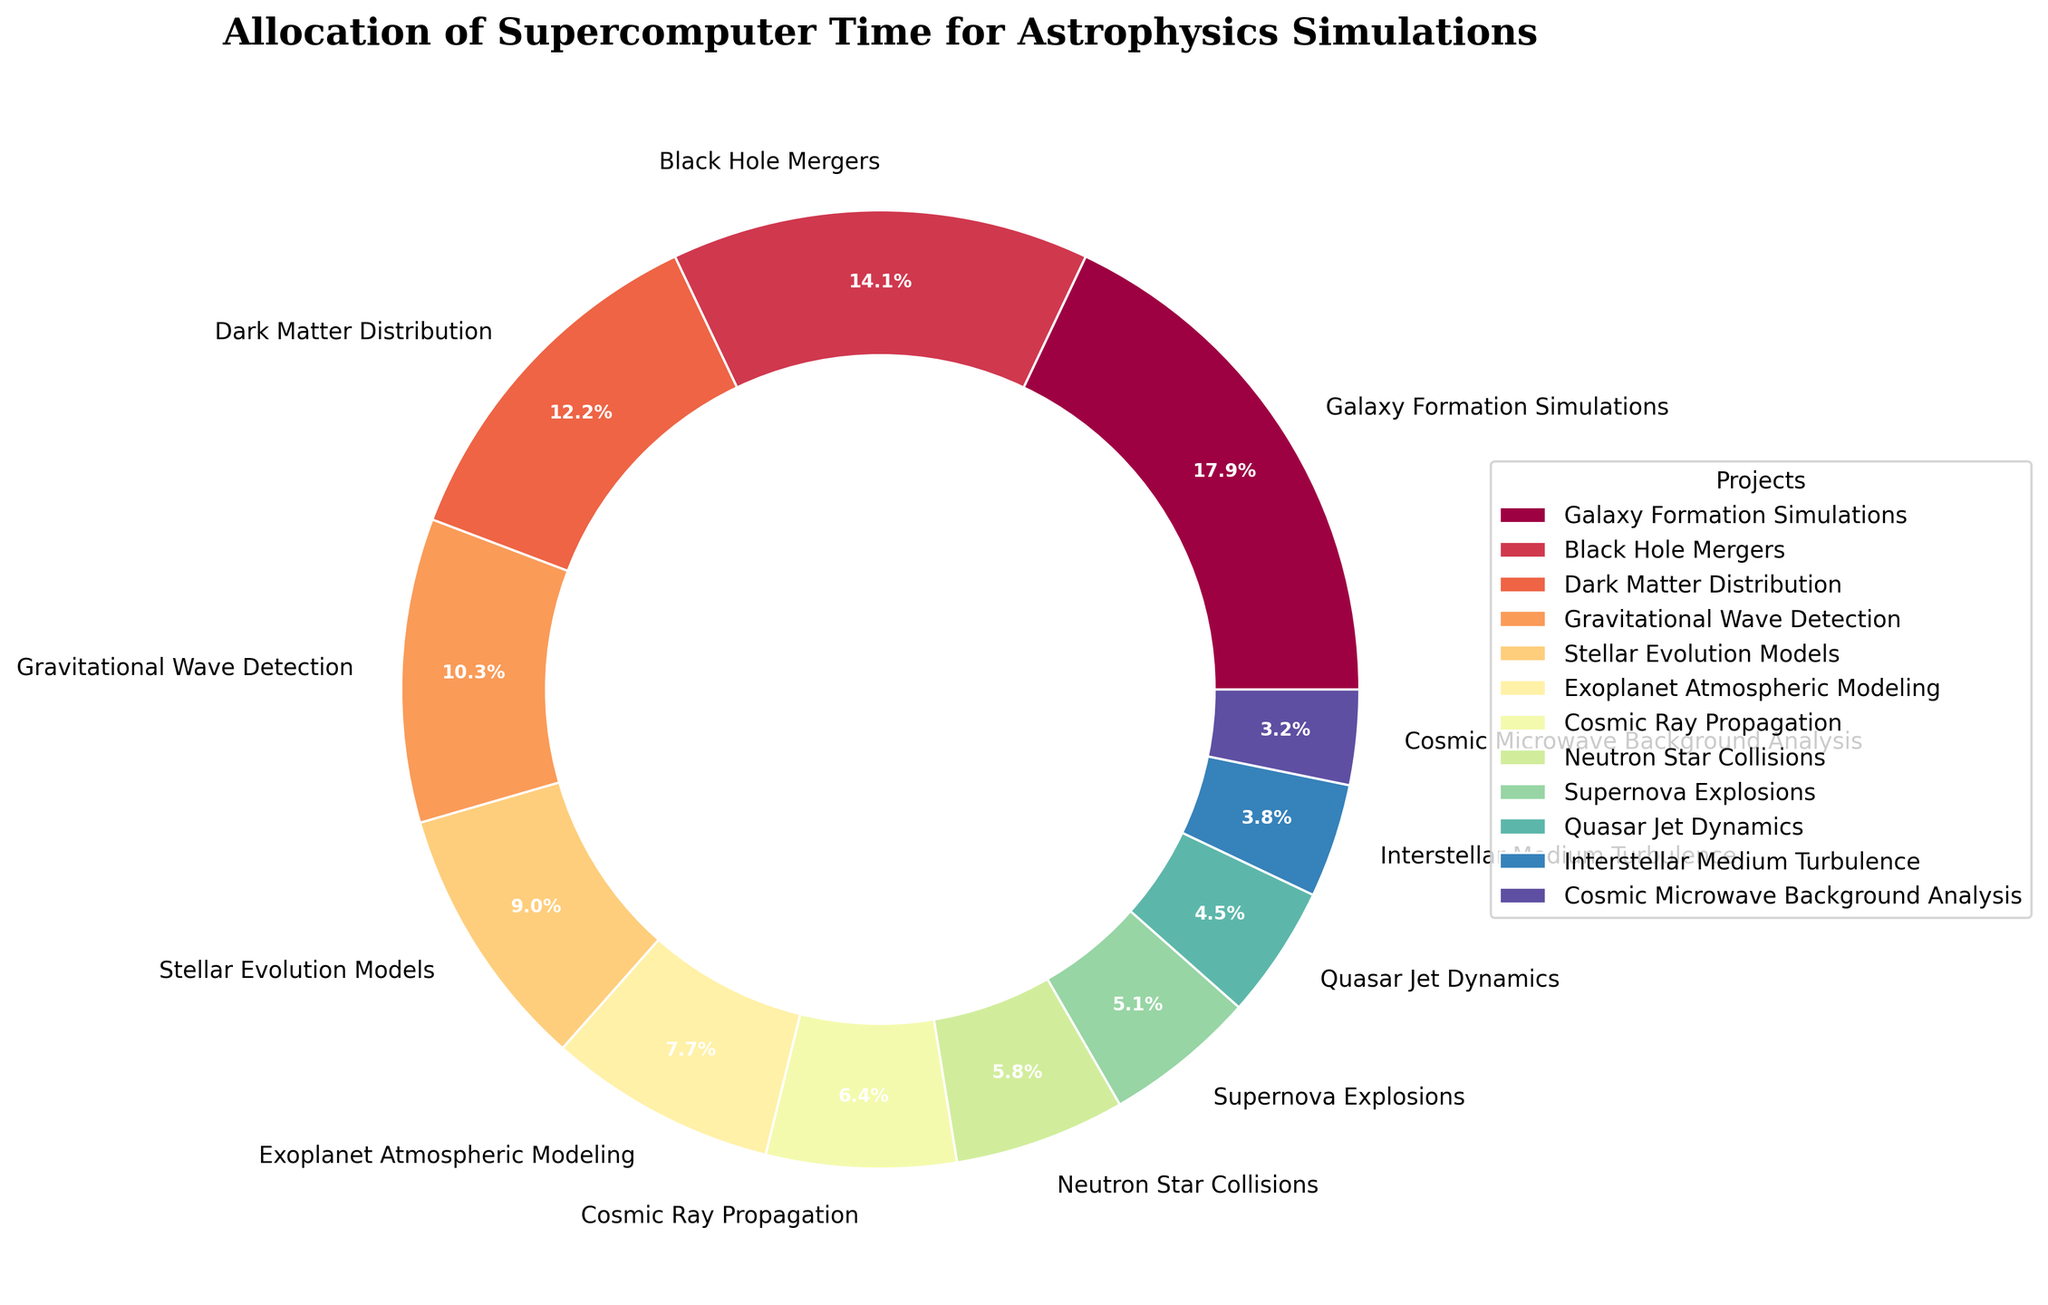what percentage of the total supercomputer time is allocated to Galaxy Formation Simulations? Look at the pie chart and find the segment labeled "Galaxy Formation Simulations." The percentage value displayed on or near this segment is the answer.
Answer: 23.1% Which project has the smallest allocation of supercomputer time? Identify the segment on the pie chart with the smallest size, which represents the smallest percentage. The label near this segment reveals the project with the smallest allocation.
Answer: Cosmic Microwave Background Analysis How much more time is allocated to Black Hole Mergers compared to Cosmic Ray Propagation? Find the segments labeled "Black Hole Mergers" and "Cosmic Ray Propagation" on the pie chart. Note their respective time allocations in hours (2200 for Black Hole Mergers, 1000 for Cosmic Ray Propagation). Subtract the smaller value from the larger one: 2200 - 1000 = 1200 hours.
Answer: 1200 hours Which two projects together account for approximately one-third of the total supercomputer time? Look for the segments on the pie chart and their respective percentages. Adding the percentages of "Black Hole Mergers" (18.1%) and "Dark Matter Distribution" (15.7%) roughly sums to 33.8%, close to one-third.
Answer: Black Hole Mergers and Dark Matter Distribution How many projects have an allocation greater than 1000 hours? Identify the segments on the pie chart where the hours allocated are more than 1000. Count these segments. Projects with allocations over 1000 hours include Galaxy Formation Simulations, Black Hole Mergers, Dark Matter Distribution, Gravitational Wave Detection, Stellar Evolution Models, and Exoplanet Atmospheric Modeling. There are 6 such projects.
Answer: 6 Which project uses more supercomputer time: Stellar Evolution Models or Gravitational Wave Detection? Compare the sizes of the segments labeled "Stellar Evolution Models" and "Gravitational Wave Detection" on the pie chart. The one with the larger segment represents the project with more time allocated.
Answer: Gravitational Wave Detection How much total time is allocated to Exoplanet Atmospheric Modeling, Cosmic Ray Propagation, and Neutron Star Collisions combined? Locate the segments for "Exoplanet Atmospheric Modeling" (1200 hours), "Cosmic Ray Propagation" (1000 hours), and "Neutron Star Collisions" (900 hours) on the pie chart. Add these hours together: 1200 + 1000 + 900 = 3100 hours.
Answer: 3100 hours Which project is allocated closer to the average supercomputer time per project? To find the average allocation, sum the total hours allocated and divide by the number of projects. Sum = 18000 hours; number of projects = 12; average = 18000/12 = 1500 hours. Compare each project's hours to find the closest one. "Stellar Evolution Models" with 1400 hours is closest to the average.
Answer: Stellar Evolution Models What is the combined percentage for the two projects with the least allocation of supercomputer time? Identify the smallest segments labeled "Cosmic Microwave Background Analysis" (2.8%) and "Interstellar Medium Turbulence" (3.3%) on the pie chart. Add these percentages together: 2.8% + 3.3% = 6.1%.
Answer: 6.1% 